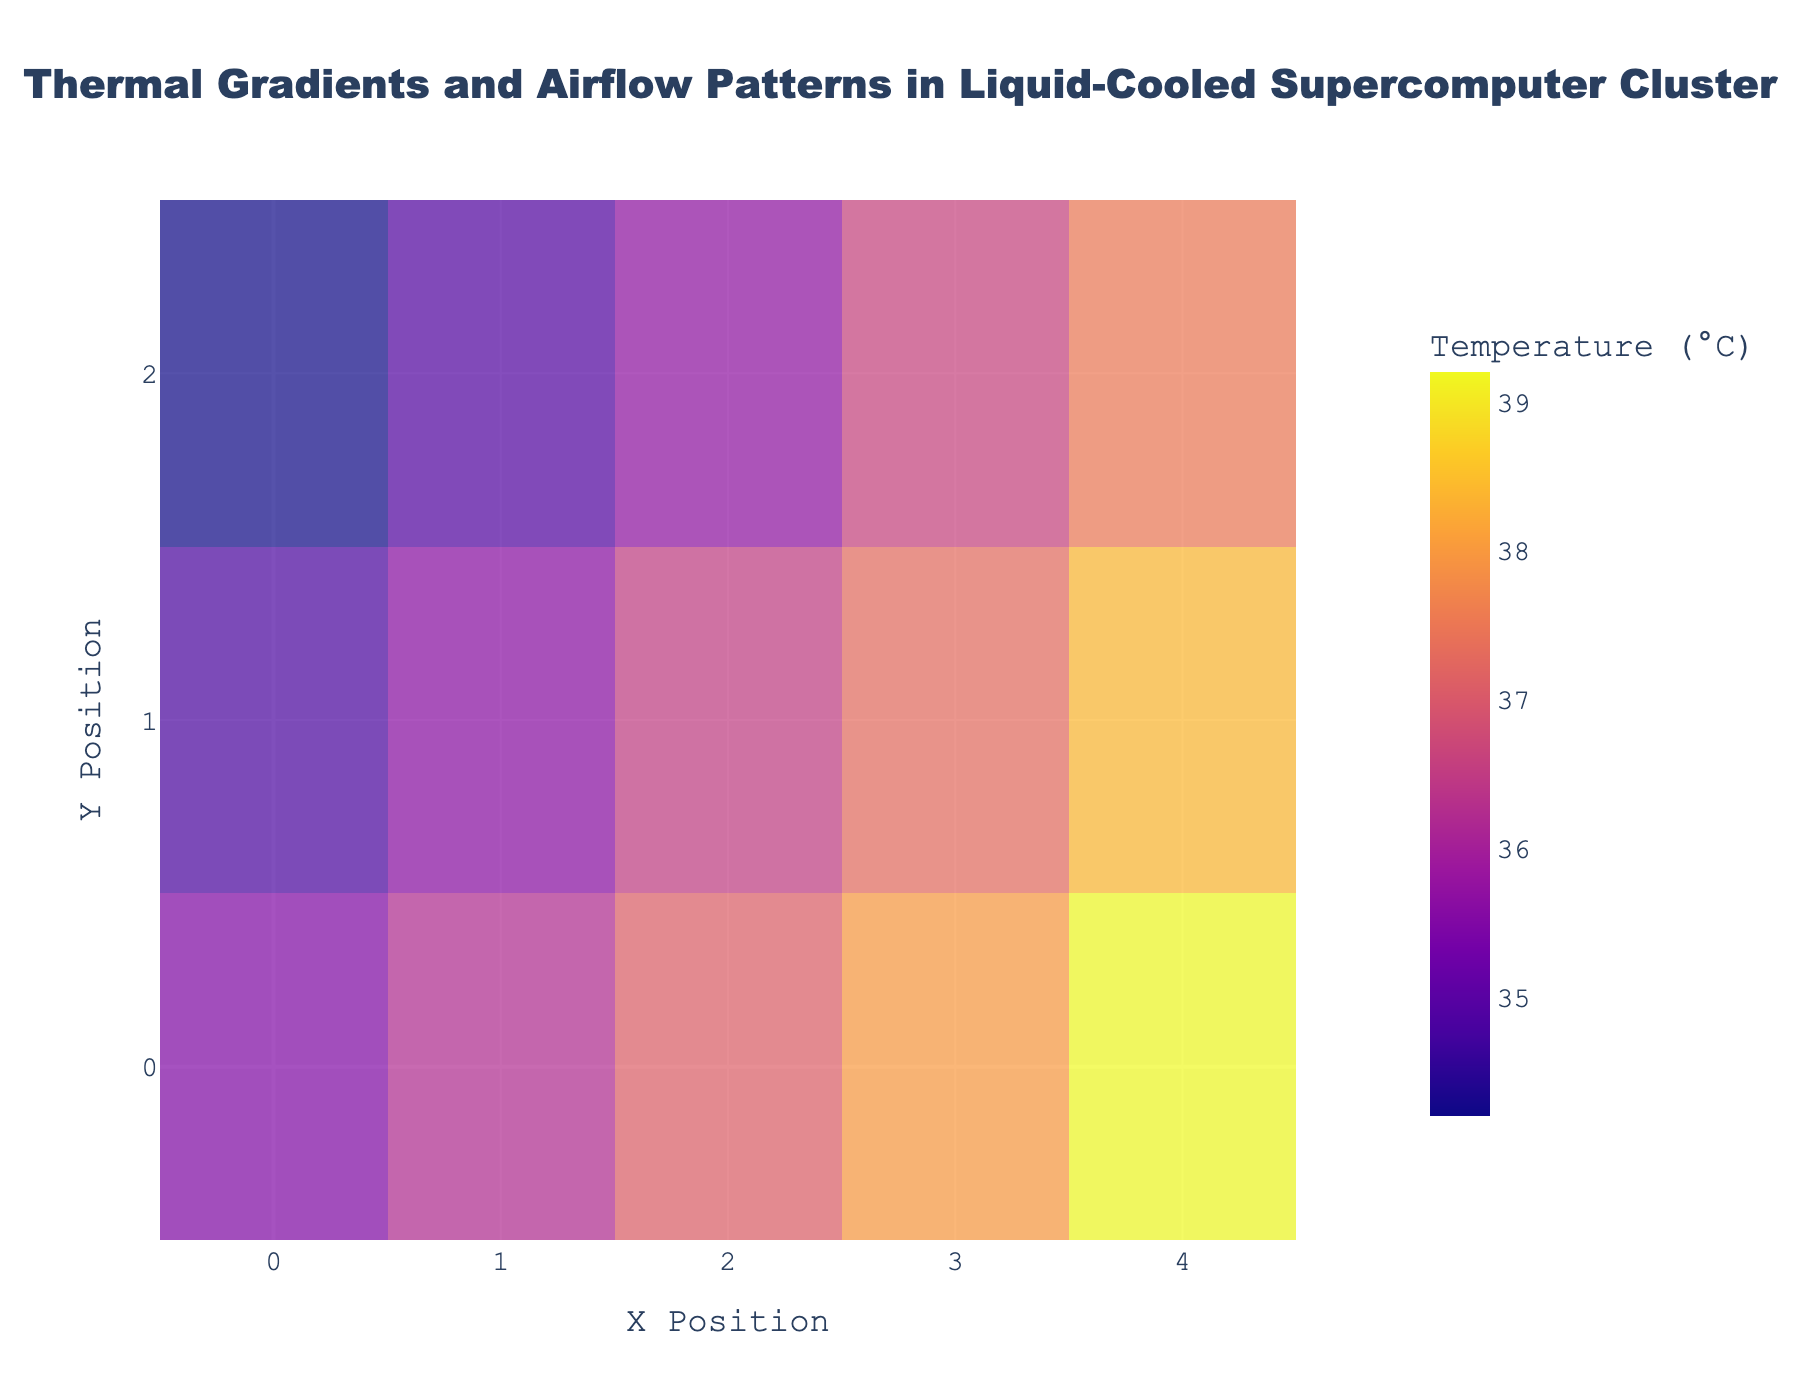What does the title of the figure indicate? The title of the figure is "Thermal Gradients and Airflow Patterns in Liquid-Cooled Supercomputer Cluster." It indicates that this figure shows the temperature distribution (thermal gradients) and the direction and strength of airflow (using quiver arrows) in a liquid-cooled supercomputer setup.
Answer: Thermal Gradients and Airflow Patterns in Liquid-Cooled Supercomputer Cluster What are the x and y positions of the data points? The x positions of the data points are 0, 1, 2, 3, and 4, while the y positions are 0, 1, and 2. These positions correspond to the grid coordinates where each data point is located.
Answer: 0, 1, 2, 3, 4 and 0, 1, 2 Which data point shows the strongest airflow in the x-direction? Look at the values of the u component, which represent the airflow in the x-direction. The data point at (4, 0) has a u value of 0.6, which is the highest among all points, indicating the strongest x-direction airflow.
Answer: (4, 0) What is the highest temperature recorded and at which position? The highest temperature can be identified from the color scale or directly from the data, which is 39.2°C. It is recorded at the position (4, 0).
Answer: 39.2°C at (4, 0) Compare the temperature at positions (1,0) and (1,1). Which one is higher? At position (1,0), the temperature is 36.2°C, and at position (1,1), it is 35.6°C. Therefore, the temperature at (1,0) is higher.
Answer: (1,0) is higher What pattern do you observe in the airflow direction across the x-axis? By observing the direction of the arrows, the airflow tends to move from the lower x-values to the higher x-values, indicating a consistent direction along the x-axis from left to right.
Answer: From lower x to higher x Compare the temperatures at the edges of the plot (x = 0 and x = 4). How do they vary? The temperature at the left edge (x = 0) ranges from 34.2°C to 35.5°C. At the right edge (x = 4), the temperature ranges from 37.5°C to 39.2°C. The right edge exhibits significantly higher temperatures compared to the left edge.
Answer: Right edge is higher If you sum the temperatures of all points along y = 1, what is the total? The temperatures along y = 1 are 34.8, 35.6, 36.5, 37.3, and 38.4. Summing these gives 34.8 + 35.6 + 36.5 + 37.3 + 38.4 = 182.6.
Answer: 182.6 Looking at the airflow arrows, which region appears to have the most turbulent flow? Turbulent flow can be inferred from the variability in arrow directions and lengths. The region around (4, 0) shows pronounced and mixed directions with high airflow magnitude, suggesting more turbulence.
Answer: Around (4, 0) What can be inferred about the cooling efficiency at position (0, 2) compared to (4, 2)? Position (0, 2) has a temperature of 34.2°C and negligible airflow (u = 0, v = 0.1), indicating it is effectively cooled. In contrast, position (4, 2) has a higher temperature of 37.5°C with higher airflow (u = 0.4, v = 0.5), indicating less effective cooling.
Answer: (0, 2) is more effectively cooled 